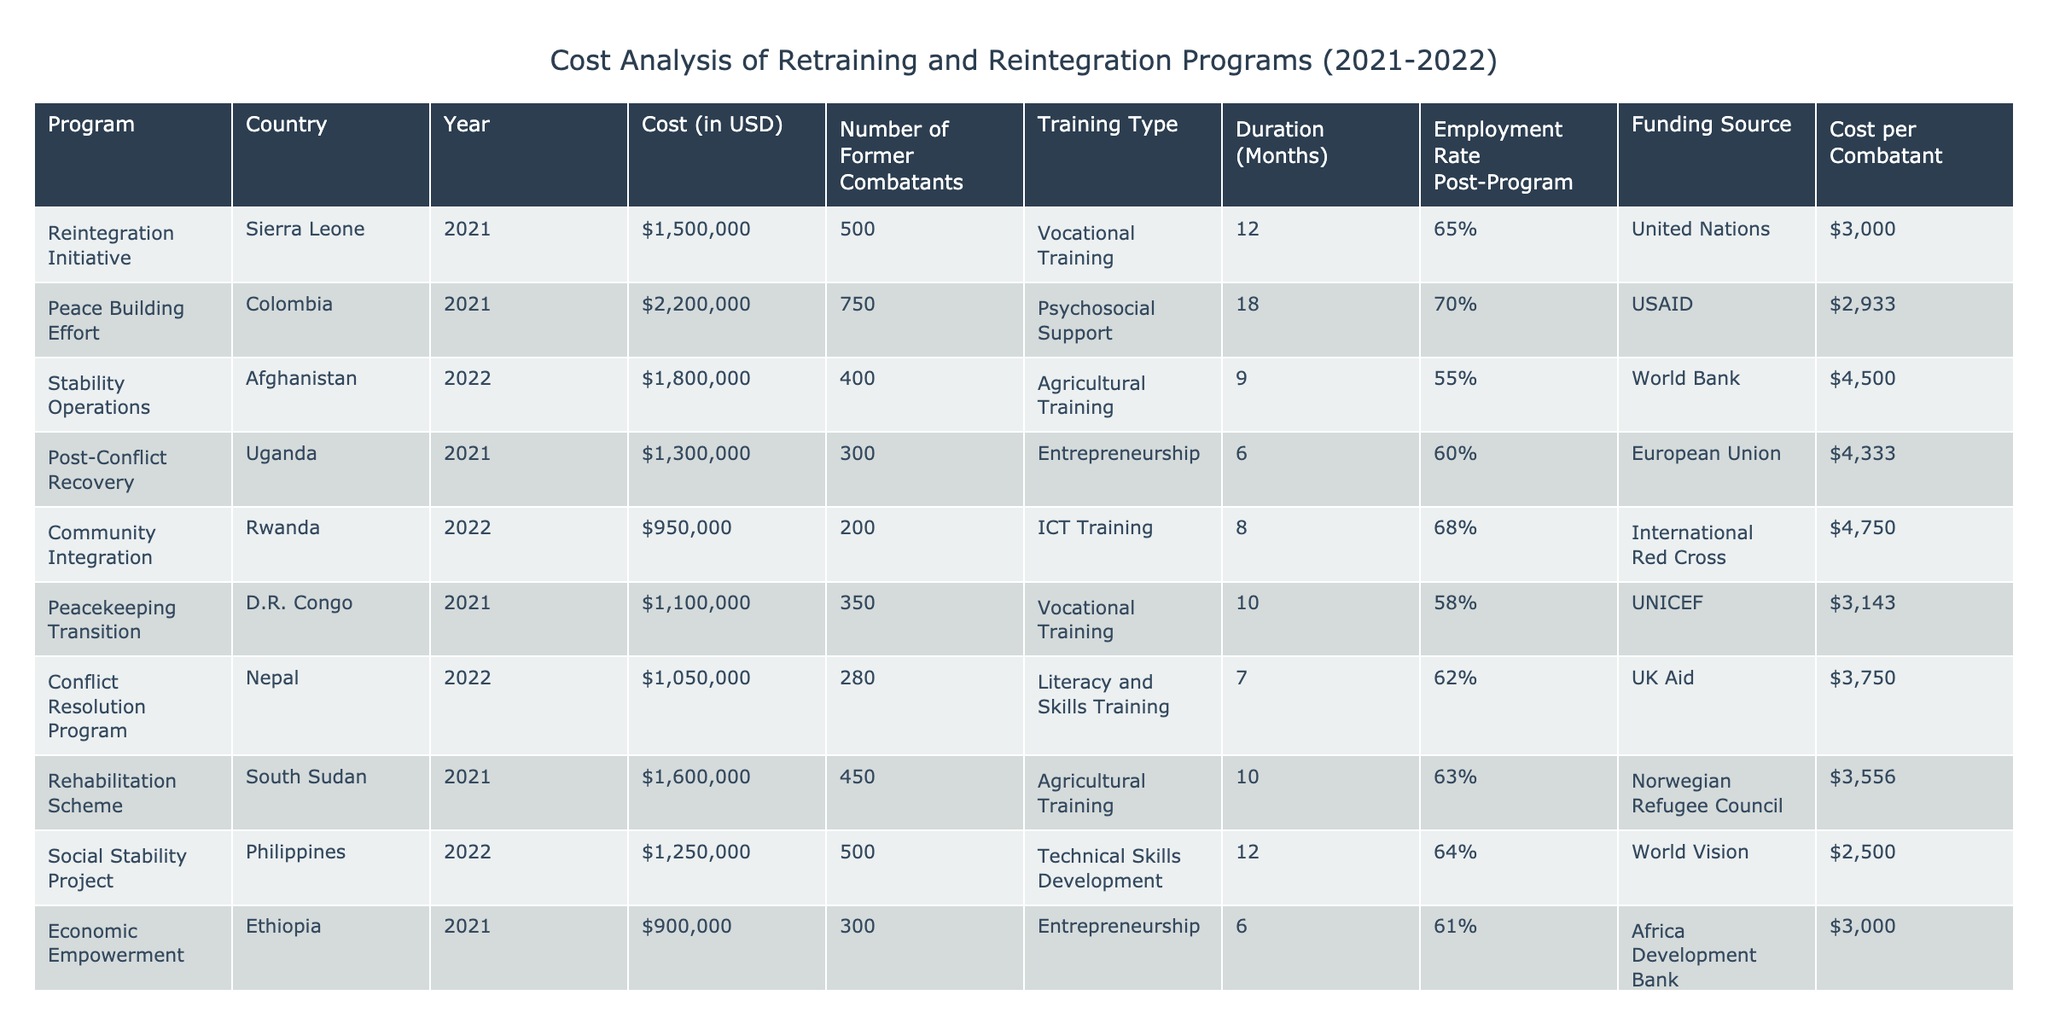What is the total cost of the Retraining and Reintegration Programs in 2021? The total cost for 2021 is calculated by adding the costs of all programs conducted that year: $1,500,000 + $2,200,000 + $1,300,000 + $1,100,000 + $1,600,000 + $900,000 = $7,600,000.
Answer: $7,600,000 Which program had the highest employment rate post-program? By inspecting the employment rates of the programs, the Peace Building Effort in Colombia has the highest at 70%.
Answer: Peace Building Effort What is the average cost per former combatant across all programs? To find the average cost per former combatant, we first calculate the cost per combatant for each program and sum these values: $3,000 (Sierra Leone) + $2,933 (Colombia) + $4,500 (Afghanistan) + $4,333 (Uganda) + $4,750 (Rwanda) + $3,143 (D.R. Congo) + $3,750 (Nepal) + $3,556 (South Sudan) + $2,500 (Philippines) + $3,000 (Ethiopia) = $3,730. The average is obtained by dividing this total by the number of programs (10): $3,730 / 10 = $373.
Answer: $3,373 Did the program in South Sudan have a higher cost than the Community Integration program in Rwanda? The cost of the Rehabilitation Scheme in South Sudan is $1,600,000 and the cost of the Community Integration program in Rwanda is $950,000. Since $1,600,000 is greater than $950,000, the statement is true.
Answer: Yes What is the total number of former combatants trained in 2022? Adding the number of former combatants from the programs in 2022: 400 (Afghanistan) + 200 (Rwanda) + 280 (Nepal) + 500 (Philippines) = 1,380.
Answer: 1,380 Which funding source provided support for the highest cost program? The Peace Building Effort in Colombia costs $2,200,000 and is funded by USAID, making it the highest cost program based on the funding source.
Answer: USAID What is the difference in employment rates between the program with the highest and the lowest employment rates? The highest employment rate is 70% (Colombia) and the lowest is 55% (Afghanistan). The difference is calculated as 70% - 55% = 15%.
Answer: 15% How many programs focused on agricultural training and what were their costs? There are two programs focusing on agricultural training: Stability Operations in Afghanistan costing $1,800,000 and Rehabilitation Scheme in South Sudan costing $1,600,000.
Answer: 2 programs; $1,800,000 and $1,600,000 